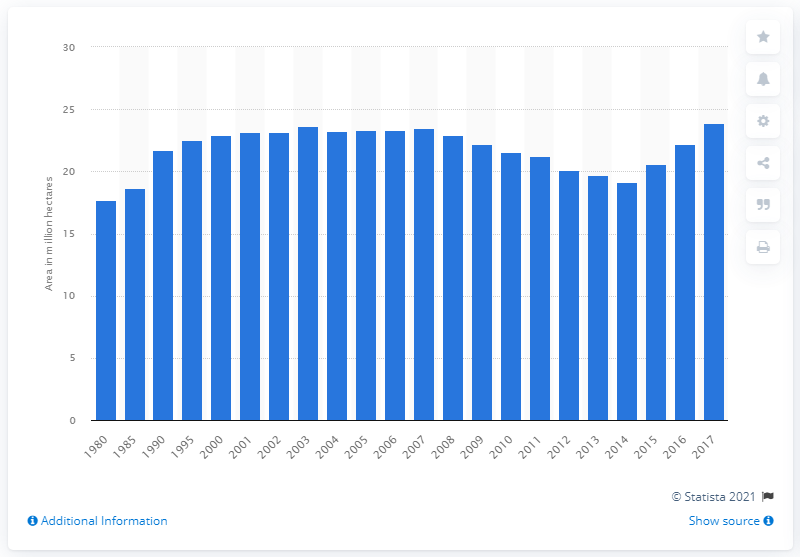Specify some key components in this picture. In 2017, the area of arable land in Mexico was approximately 23.91.. 